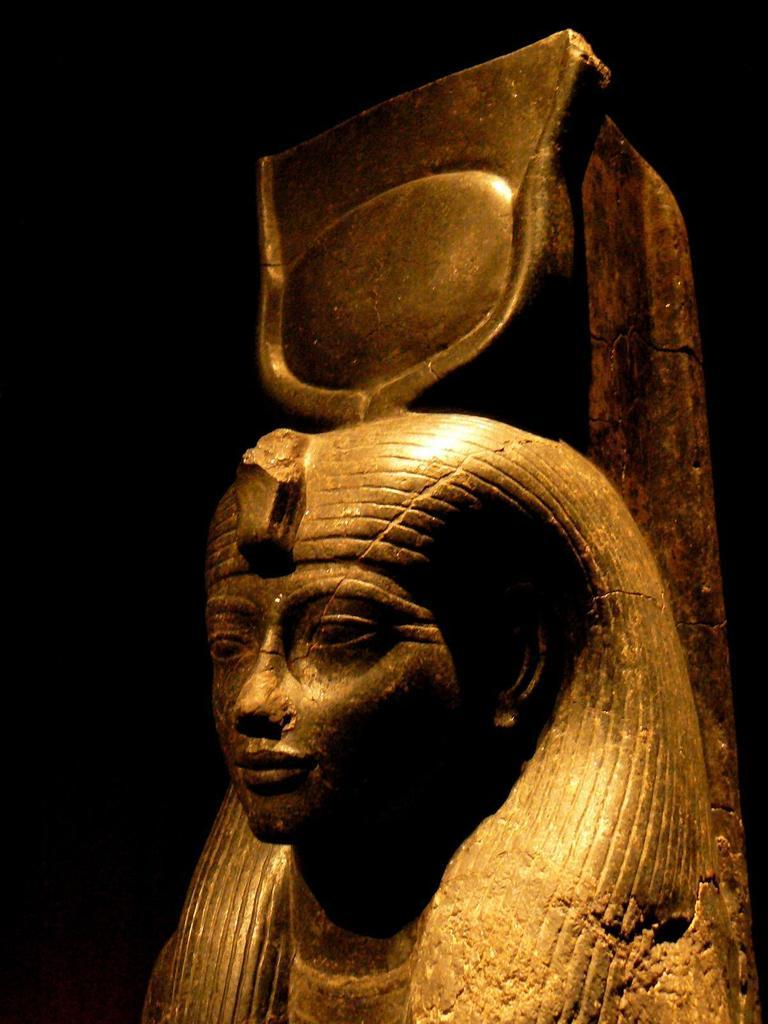What is the main subject in the image? There is a statue in the image. What type of office can be seen in the background of the image? There is no office present in the image; it only features a statue. What advice might the statue's mom give to her in the image? There is no mom or advice-giving scenario present in the image, as it only features a statue. 